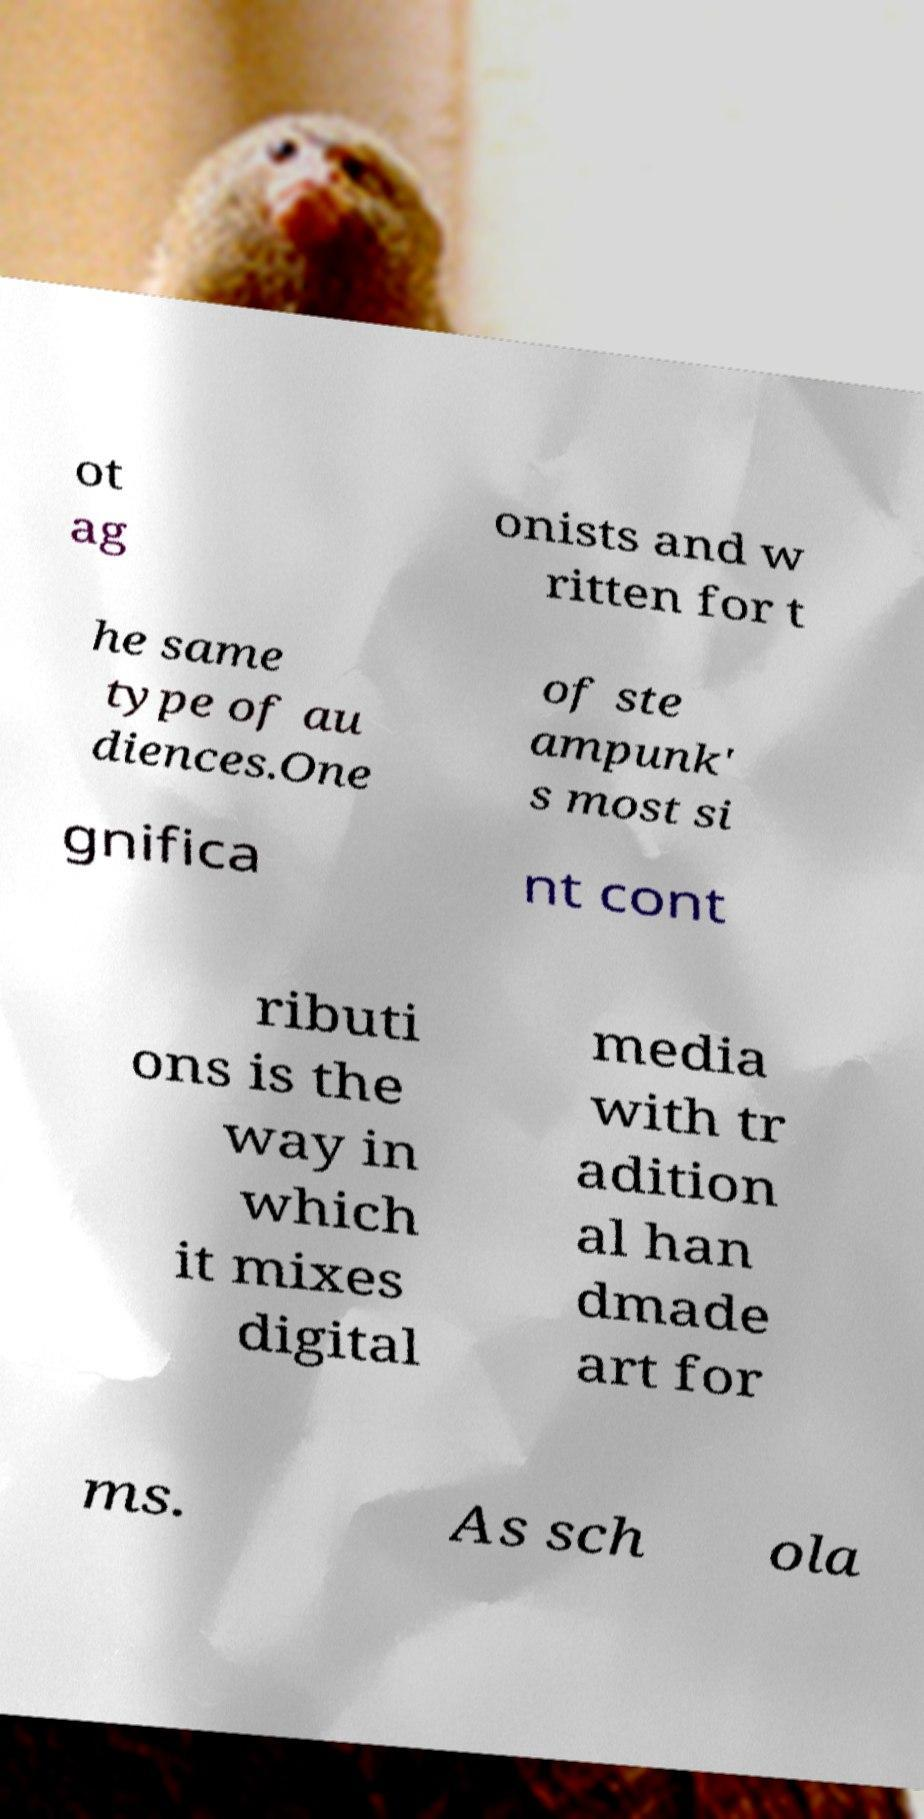Could you assist in decoding the text presented in this image and type it out clearly? ot ag onists and w ritten for t he same type of au diences.One of ste ampunk' s most si gnifica nt cont ributi ons is the way in which it mixes digital media with tr adition al han dmade art for ms. As sch ola 